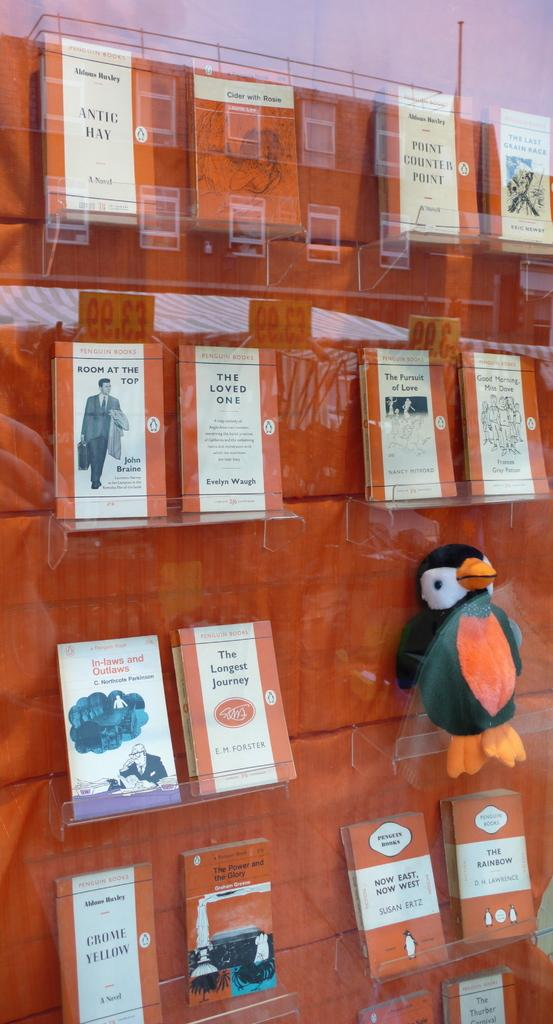Provide a one-sentence caption for the provided image. A scene at a bookstore with a wooden wall featuring several book including one called The Loved One. 